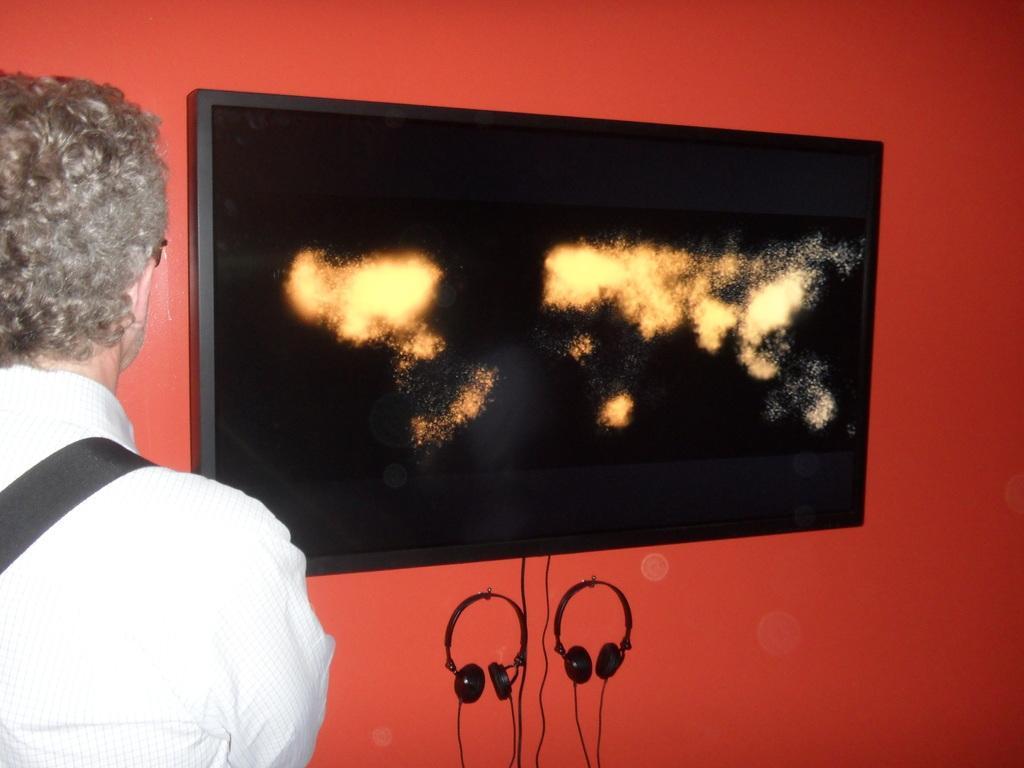Describe this image in one or two sentences. In this picture I can see a person on the left side. I can see the screen on the wall. I can see the microphones. 